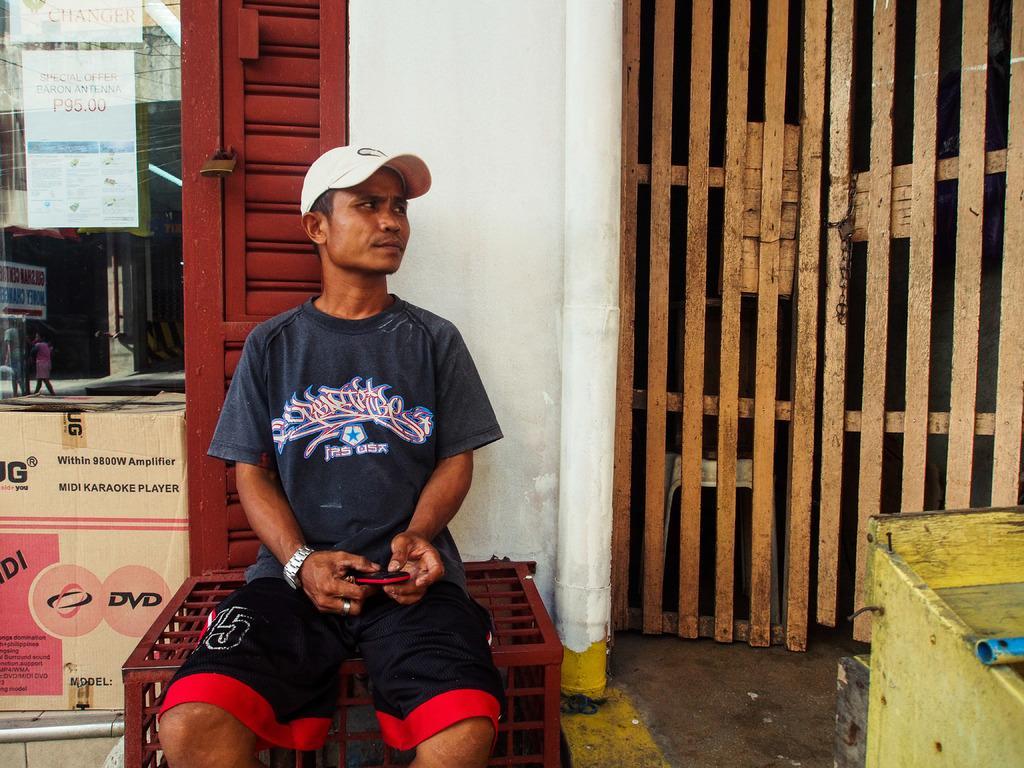Could you give a brief overview of what you see in this image? In the center of the picture there is a person holding mobile, wearing watch and cap, sitting on a thing. On the right there are door box and an object. On the left there is a glass window, on the glass there are posters. 